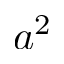Convert formula to latex. <formula><loc_0><loc_0><loc_500><loc_500>a ^ { 2 }</formula> 